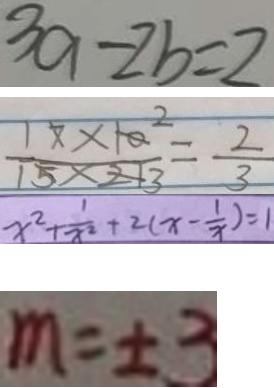Convert formula to latex. <formula><loc_0><loc_0><loc_500><loc_500>3 9 - 2 b = 2 
 \frac { 1 7 \times 1 0 ^ { 2 } } { 1 5 \times 2 1 3 } = \frac { 2 } { 3 } 
 x ^ { 2 } + \frac { 1 } { x ^ { 2 } } + 2 ( x - \frac { 1 } { x } ) = 1 
 m = \pm 3</formula> 